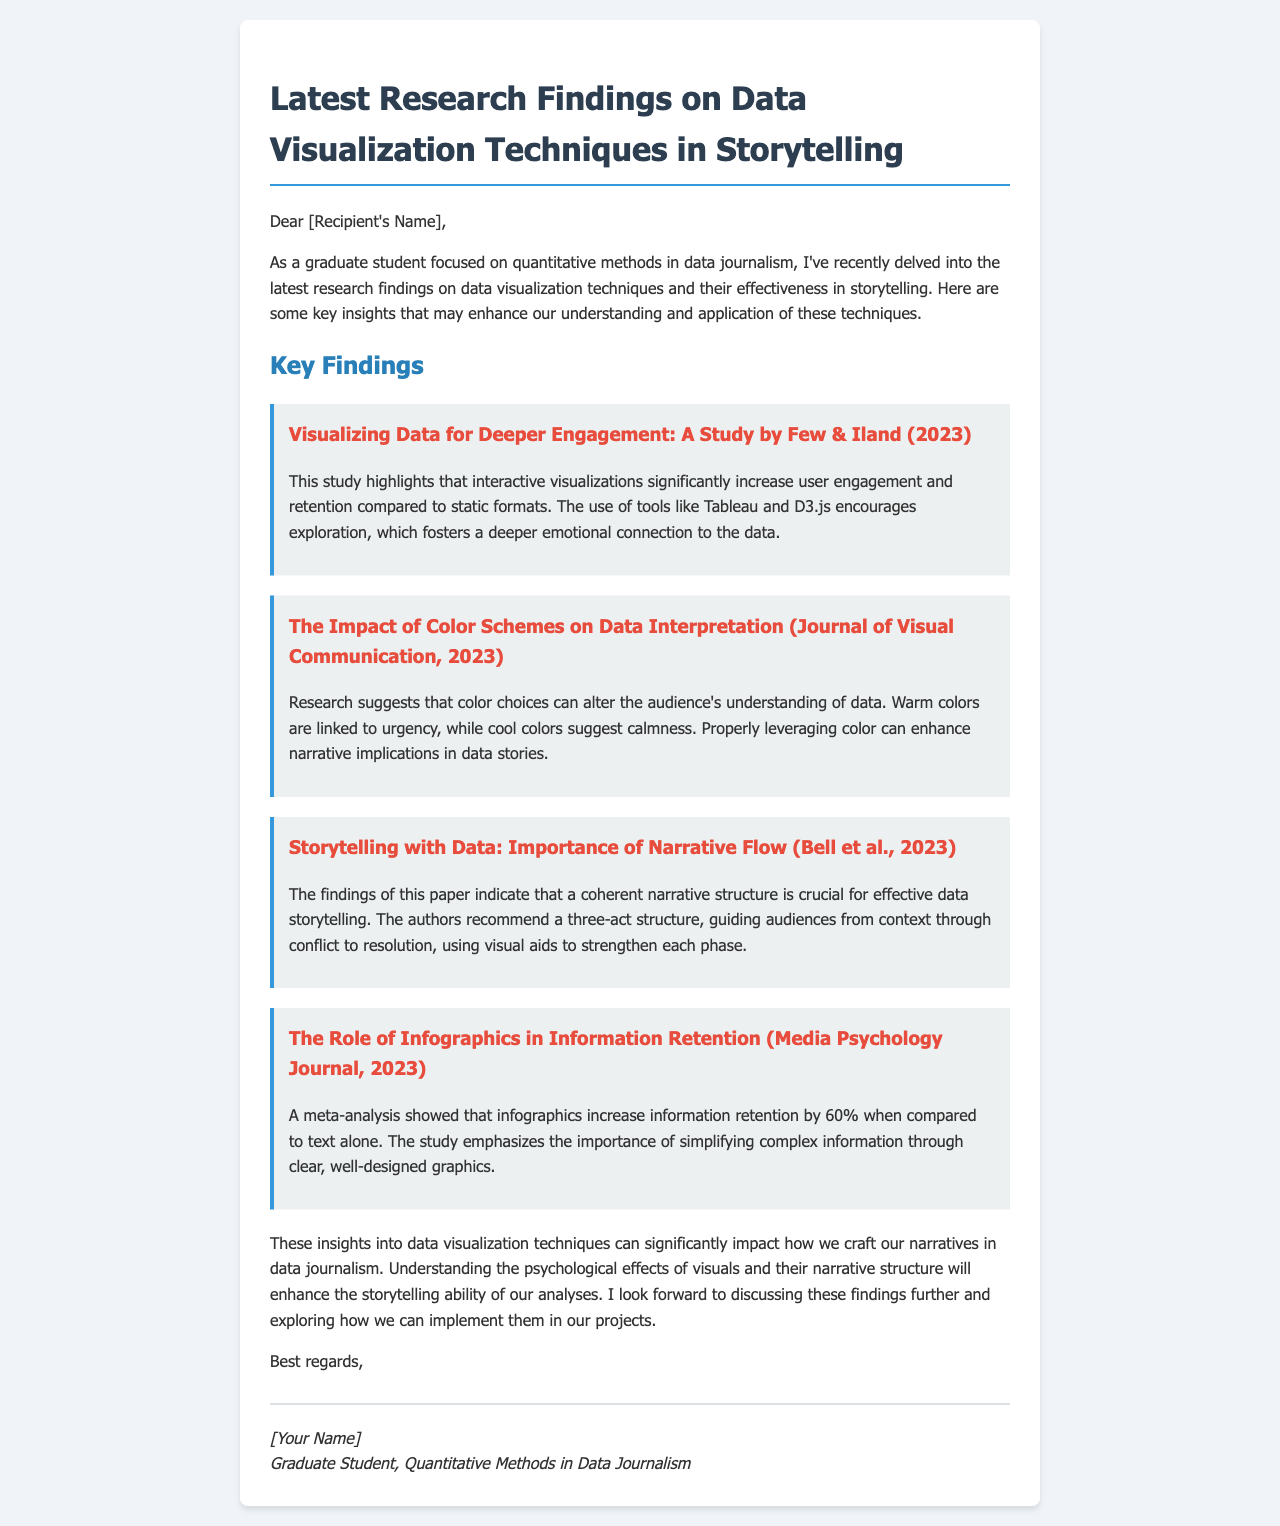What is the title of the email? The title is found in the header of the email, which introduces the main topic.
Answer: Latest Research Findings on Data Visualization Techniques in Storytelling Who conducted the study on engaging visualizations? The authors of the study are mentioned in the key findings section, and they provide valuable insights on engagement.
Answer: Few & Iland What year was the research on color schemes published? This information is listed within the source citation of the corresponding key finding.
Answer: 2023 What is the impact of infographics according to the meta-analysis? The document specifies the effect of infographics compared to text, focusing on retention rates.
Answer: Increase information retention by 60% What narrative structure is recommended for data storytelling? The suggested structure is stated explicitly in one of the key findings, pointing towards its effectiveness.
Answer: Three-act structure Which data visualization tools are mentioned for enhancing engagement? The tools are identified in the first key finding, illustrating their role in user engagement.
Answer: Tableau and D3.js What color implication is associated with warm colors? The document describes how certain colors can influence audience perception in the context of urgency.
Answer: Urgency What is a crucial aspect of effective data storytelling? This aspect is highlighted in the findings regarding narrative structure in storytelling with data.
Answer: Coherent narrative structure 